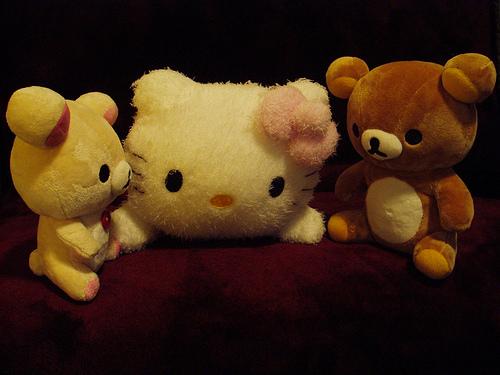Are these toys packaged in the store?
Concise answer only. No. Which teddy bear is wearing a ribbon?
Give a very brief answer. Left. What is the bear doing?
Be succinct. Sitting. Are the teddie dressed?
Give a very brief answer. No. How many stuffed animals are there?
Concise answer only. 3. What color is the stuff animals?
Give a very brief answer. White. What is the stuffed animal in the middle?
Write a very short answer. Hello kitty. 